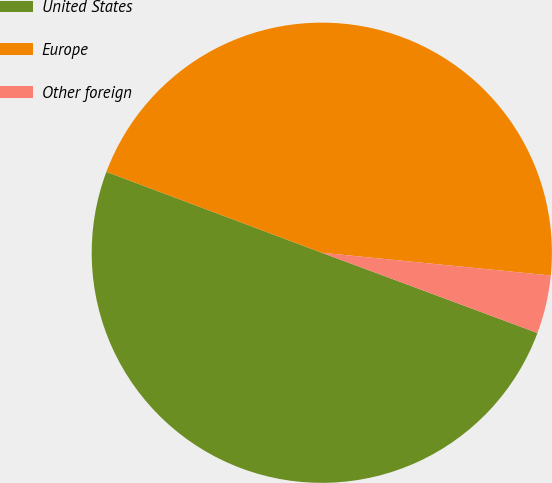Convert chart. <chart><loc_0><loc_0><loc_500><loc_500><pie_chart><fcel>United States<fcel>Europe<fcel>Other foreign<nl><fcel>50.05%<fcel>45.86%<fcel>4.09%<nl></chart> 